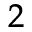<formula> <loc_0><loc_0><loc_500><loc_500>^ { 2 }</formula> 